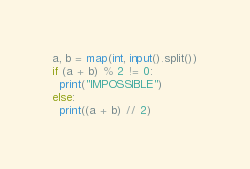<code> <loc_0><loc_0><loc_500><loc_500><_Python_>a, b = map(int, input().split())
if (a + b) % 2 != 0:
  print("IMPOSSIBLE")
else:
  print((a + b) // 2)</code> 